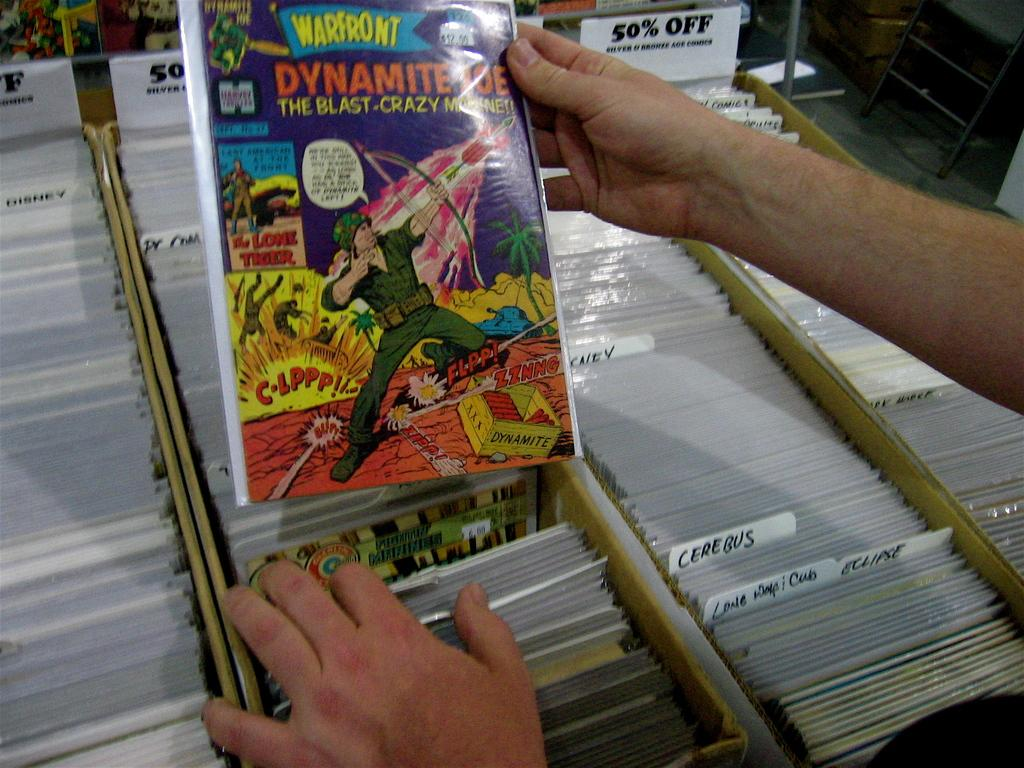<image>
Present a compact description of the photo's key features. A man looks at a "warfront" comic book from the stacks of comic books. 